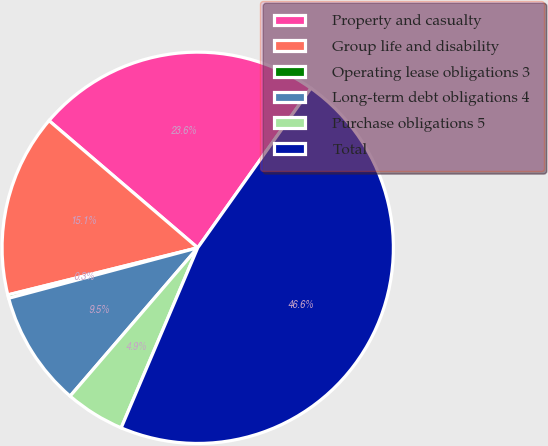<chart> <loc_0><loc_0><loc_500><loc_500><pie_chart><fcel>Property and casualty<fcel>Group life and disability<fcel>Operating lease obligations 3<fcel>Long-term debt obligations 4<fcel>Purchase obligations 5<fcel>Total<nl><fcel>23.56%<fcel>15.13%<fcel>0.28%<fcel>9.54%<fcel>4.91%<fcel>46.58%<nl></chart> 